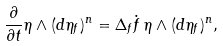<formula> <loc_0><loc_0><loc_500><loc_500>\frac { \partial } { \partial t } \eta \wedge ( d \eta _ { f } ) ^ { n } = \Delta _ { f } \dot { f } \, \eta \wedge ( d \eta _ { f } ) ^ { n } ,</formula> 